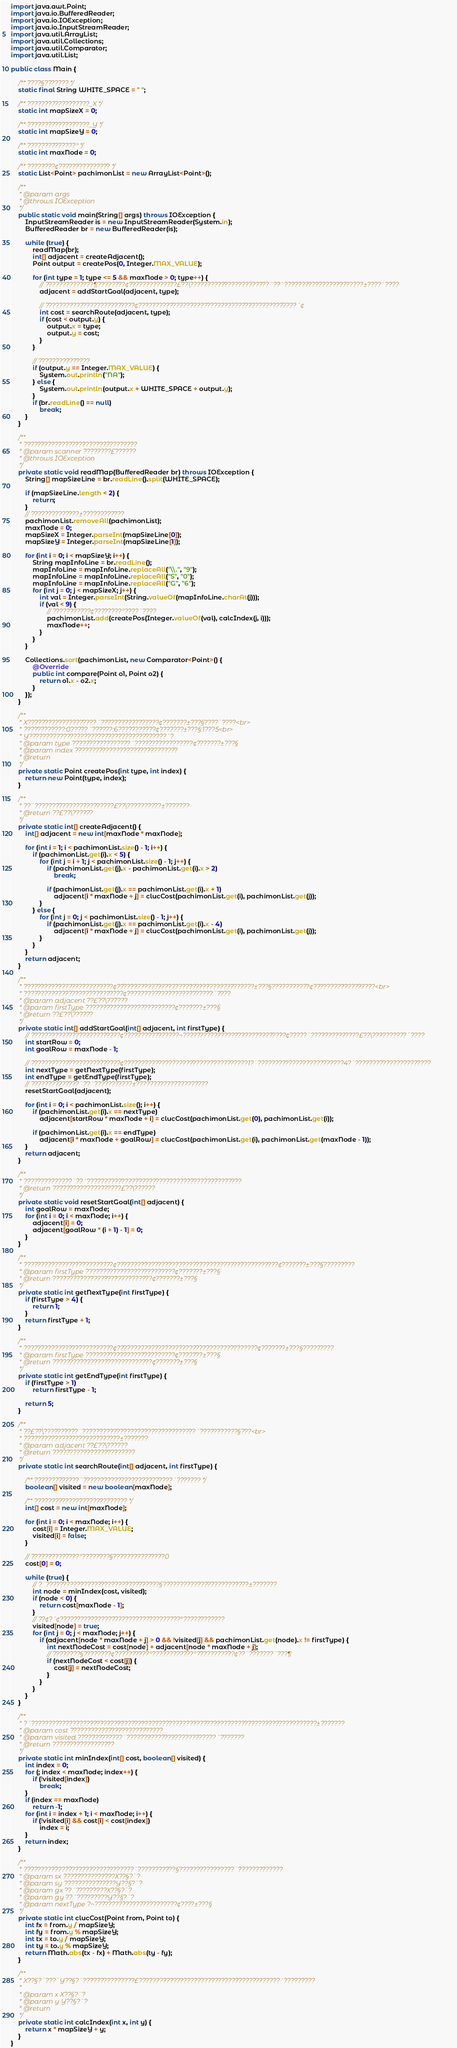<code> <loc_0><loc_0><loc_500><loc_500><_Java_>import java.awt.Point;
import java.io.BufferedReader;
import java.io.IOException;
import java.io.InputStreamReader;
import java.util.ArrayList;
import java.util.Collections;
import java.util.Comparator;
import java.util.List;

public class Main {

	/** ????§??????? */
	static final String WHITE_SPACE = " ";

	/** ??????????????????_X */
	static int mapSizeX = 0;

	/** ??????????????????_Y */
	static int mapSizeY = 0;

	/** ??????????????° */
	static int maxNode = 0;

	/** ????????¢??????????????? */
	static List<Point> pachimonList = new ArrayList<Point>();

	/**
	 * @param args
	 * @throws IOException
	 */
	public static void main(String[] args) throws IOException {
		InputStreamReader is = new InputStreamReader(System.in);
		BufferedReader br = new BufferedReader(is);

		while (true) {
			readMap(br);
			int[] adjacent = createAdjacent();
			Point output = createPos(0, Integer.MAX_VALUE);

			for (int type = 1; type <= 5 && maxNode > 0; type++) {
				// ??????????????¶????????¢??????????????£??\???????????????????????¨??´???????????????????????±????¨????
				adjacent = addStartGoal(adjacent, type);

				// ??????????????????????????¢??????????????????????????????????????????????´¢
				int cost = searchRoute(adjacent, type);
				if (cost < output.y) {
					output.x = type;
					output.y = cost;
				}
			}

			// ???????????????
			if (output.y == Integer.MAX_VALUE) {
				System.out.println("NA");
			} else {
				System.out.println(output.x + WHITE_SPACE + output.y);
			}
			if (br.readLine() == null)
				break;
		}
	}

	/**
	 * ?????????????????????????????????
	 * @param scanner ????????£??????
	 * @throws IOException
	 */
	private static void readMap(BufferedReader br) throws IOException {
		String[] mapSizeLine = br.readLine().split(WHITE_SPACE);

		if (mapSizeLine.length < 2) {
			return;
		}
		// ??????????????±????????????
		pachimonList.removeAll(pachimonList);
		maxNode = 0;
		mapSizeX = Integer.parseInt(mapSizeLine[0]);
		mapSizeY = Integer.parseInt(mapSizeLine[1]);

		for (int i = 0; i < mapSizeY; i++) {
			String mapInfoLine = br.readLine();
			mapInfoLine = mapInfoLine.replaceAll("\\.", "9");
			mapInfoLine = mapInfoLine.replaceAll("S", "0");
			mapInfoLine = mapInfoLine.replaceAll("G", "6");
			for (int j = 0; j < mapSizeX; j++) {
				int val = Integer.parseInt(String.valueOf(mapInfoLine.charAt(j)));
				if (val < 9) {
					// ???????????¢????????°????¨????
					pachimonList.add(createPos(Integer.valueOf(val), calcIndex(j, i)));
					maxNode++;
				}
			}
		}

		Collections.sort(pachimonList, new Comparator<Point>() {
			@Override
			public int compare(Point o1, Point o2) {
				return o1.x - o2.x;
			}
		});
	}

	/**
	 * X????????????????????´?????????????????¢???????±???§????¨????<br>
	 * ????????????:0?????´??????:6???????????¢???????±???§:1???5<br>
	 * Y????????????????????????????????????????´?
	 * @param type ?????????????????´?????????????????¢???????±???§
	 * @param index ??????????????????????????????
	 * @return
	 */
	private static Point createPos(int type, int index) {
		return new Point(type, index);
	}

	/**
	 * ??¨???????????????????????£??\??????????±???????
	 * @return ??£??\??????
	 */
	private static int[] createAdjacent() {
		int[] adjacent = new int[maxNode * maxNode];

		for (int i = 1; i < pachimonList.size() - 1; i++) {
			if (pachimonList.get(i).x < 5) {
				for (int j = i + 1; j < pachimonList.size() - 1; j++) {
					if (pachimonList.get(j).x - pachimonList.get(i).x > 2)
						break;

					if (pachimonList.get(j).x == pachimonList.get(i).x + 1)
						adjacent[i * maxNode + j] = clucCost(pachimonList.get(i), pachimonList.get(j));
				}
			} else {
				for (int j = 0; j < pachimonList.size() - 1; j++) {
					if (pachimonList.get(j).x == pachimonList.get(i).x - 4)
						adjacent[i * maxNode + j] = clucCost(pachimonList.get(i), pachimonList.get(j));
				}
			}
		}
		return adjacent;
	}

	/**
	 * ??????????????????????????¢????????????????????????????????????????±???§???????????¢??????????????????<br>
	 * ?????????????????????????????¢?????????????????????????¨????
	 * @param adjacent ??£??\??????
	 * @param firstType ??????????????????????????¢???????±???§
	 * @return ??£??\??????
	 */
	private static int[] addStartGoal(int[] adjacent, int firstType) {
		// ??????????????????????????¢????????????????¬??????????????????????????????¢?????¨??????????????£??\??????????¨????
		int startRow = 0;
		int goalRow = maxNode - 1;

		// ??????????????????????????¢????????????????????????????????????1?¨?????????????????????????4?¨??????????????????????
		int nextType = getNextType(firstType);
		int endType = getEndType(firstType);
		// ??????????????¨??´???????????±?????????????????????
		resetStartGoal(adjacent);

		for (int i = 0; i < pachimonList.size(); i++) {
			if (pachimonList.get(i).x == nextType)
				adjacent[startRow * maxNode + i] = clucCost(pachimonList.get(0), pachimonList.get(i));

			if (pachimonList.get(i).x == endType)
				adjacent[i * maxNode + goalRow] = clucCost(pachimonList.get(i), pachimonList.get(maxNode - 1));
		}
		return adjacent;
	}

	/**
	 * ??????????????¨??´?????????????????????????????????????????????
	 * @return ????????????????????£??\??????
	 */
	private static void resetStartGoal(int[] adjacent) {
		int goalRow = maxNode;
		for (int i = 0; i < maxNode; i++) {
			adjacent[i] = 0;
			adjacent[goalRow * (i + 1) - 1] = 0;
		}
	}

	/**
	 * ??????????????????????????¢???????????????????????????????????????????????¢???????±???§?????????
	 * @param firstType ??????????????????????????¢???????±???§
	 * @return ?????????????????????????????¢???????±???§
	 */
	private static int getNextType(int firstType) {
		if (firstType > 4) {
			return 1;
		}
		return firstType + 1;
	}

	/**
	 * ??????????????????????????¢?????????????????????????????????????????¢???????±???§?????????
	 * @param firstType ??????????????????????????¢???????±???§
	 * @return ?????????????????????????????¢???????±???§
	 */
	private static int getEndType(int firstType) {
		if (firstType > 1)
			return firstType - 1;

		return 5;
	}

	/**
	 * ??£??\??????????¨?????????????????????????????????´???????????§???<br>
	 * ????????????????????????????±???????
	 * @param adjacent ??£??\??????
	 * @return ????????????????????????
	 */
	private static int searchRoute(int[] adjacent, int firstType) {

		/** ?????????????¨??????????????????????????´??????? */
		boolean[] visited = new boolean[maxNode];

		/** ??????????????????????????? */
		int[] cost = new int[maxNode];

		for (int i = 0; i < maxNode; i++) {
			cost[i] = Integer.MAX_VALUE;
			visited[i] = false;
		}

		// ??????????????°????????§???????????????0
		cost[0] = 0;

		while (true) {
			// ?¨?????????????????????????????????§?????????????????????????±???????
			int node = minIndex(cost, visited);
			if (node < 0) {
				return cost[maxNode - 1];
			}
			// ??¢?´¢???????????????????????????????????°????????????
			visited[node] = true;
			for (int j = 0; j < maxNode; j++) {
				if (adjacent[node * maxNode + j] > 0 && !visited[j] && pachimonList.get(node).x != firstType) {
					int nextNodeCost = cost[node] + adjacent[node * maxNode + j];
					// ????????§????????¢??????????°????????????°???????????¢??¨???????¨???¶
					if (nextNodeCost < cost[j]) {
						cost[j] = nextNodeCost;
					}
				}
			}
		}
	}

	/**
	 * ?¨???????????????????????????????????????????????????????????????????????????????????±???????
	 * @param cost ???????????????????????????
	 * @param visited ?????????????¨??????????????????????????´???????
	 * @return ??????????????????
	 */
	private static int minIndex(int[] cost, boolean[] visited) {
		int index = 0;
		for (; index < maxNode; index++) {
			if (!visited[index])
				break;
		}
		if (index == maxNode)
			return -1;
		for (int i = index + 1; i < maxNode; i++) {
			if (!visited[i] && cost[i] < cost[index])
				index = i;
		}
		return index;
	}

	/**
	 * ????????????????????????????????´???????????§????????????????¨?????????????
	 * @param sx ???????????????X??§?¨?
	 * @param sy ???????????????Y??§?¨?
	 * @param gx ??´?????????X??§?¨?
	 * @param gy ??´?????????Y??§?¨?
	 * @param nextType ?¬????????????????????????¢????±???§
	 */
	private static int clucCost(Point from, Point to) {
		int fx = from.y / mapSizeY;
		int fy = from.y % mapSizeY;
		int tx = to.y / mapSizeY;
		int ty = to.y % mapSizeY;
		return Math.abs(tx - fx) + Math.abs(ty - fy);
	}

	/**
	 * X??§?¨???¨Y??§?¨???????????????£?????????????????????????????????????????´?????????
	 *
	 * @param x X??§?¨?
	 * @param y Y??§?¨?
	 * @return
	 */
	private static int calcIndex(int x, int y) {
		return x * mapSizeY + y;
	}
}</code> 